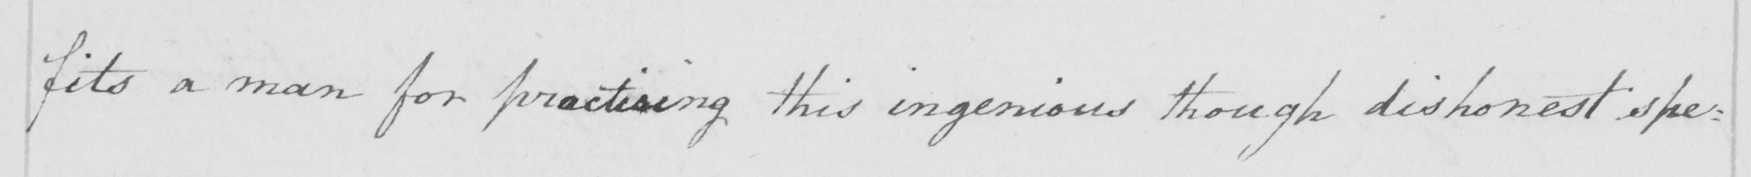What is written in this line of handwriting? fits a man for practising this ingenious though dishonest spe= 